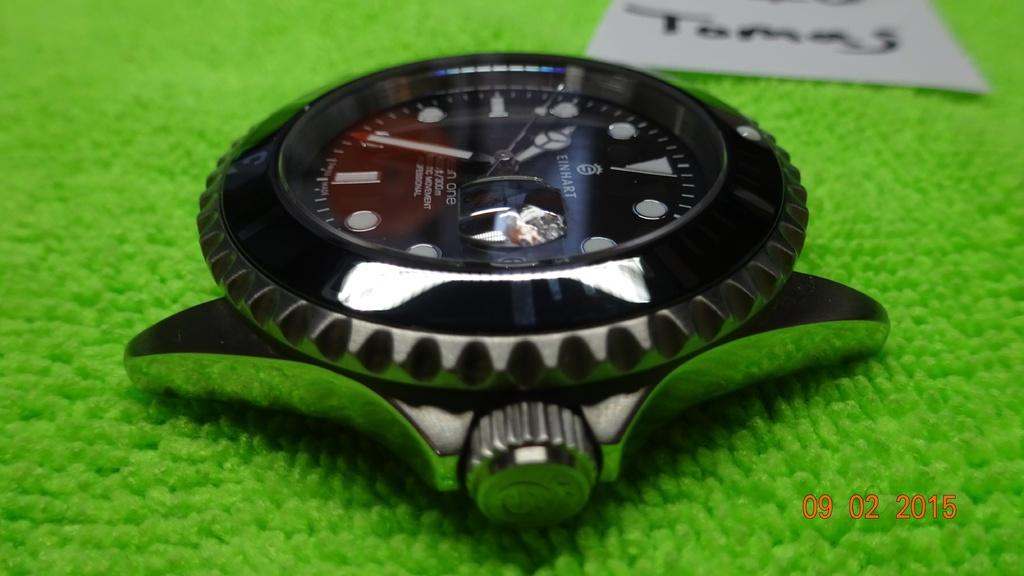What object is the main focus of the image? There is a wristwatch in the image. What is the wristwatch placed on? The wristwatch is on a green color mat. What else can be seen in the image besides the wristwatch? There is a paper in the image. What is written on the paper? The paper has text and numbers written on it. How many balls are visible in the image? There are no balls present in the image. What type of light source is illuminating the wristwatch in the image? The image does not provide information about a light source; it only shows the wristwatch on a green color mat. 